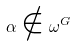Convert formula to latex. <formula><loc_0><loc_0><loc_500><loc_500>\alpha \notin \omega ^ { G }</formula> 